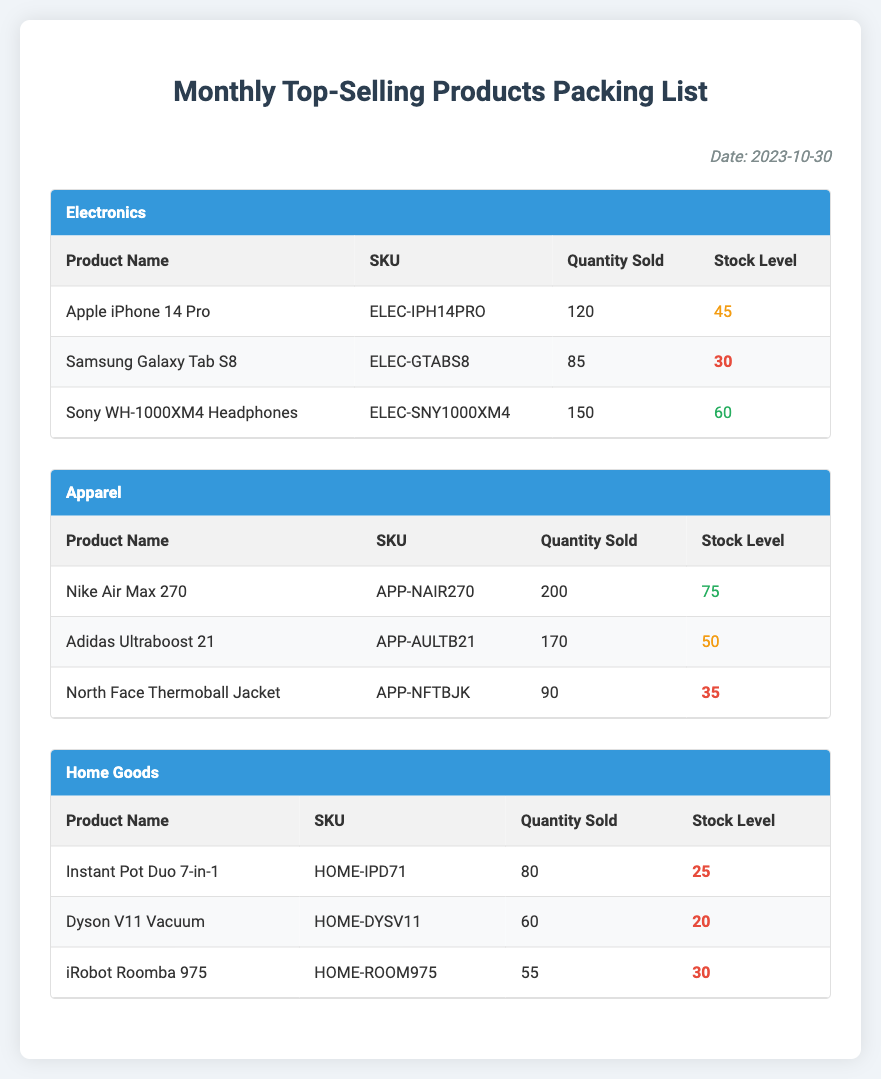What date is mentioned in the document? The document includes the date at the top right of the packing list, which is "2023-10-30."
Answer: 2023-10-30 How many quantities of the Apple iPhone 14 Pro were sold? The packing list shows that the quantity sold for the Apple iPhone 14 Pro is listed in the electronics category as "120."
Answer: 120 What is the stock level of the Dyson V11 Vacuum? The stock level for the Dyson V11 Vacuum can be found under the home goods category, which is "20."
Answer: 20 Which apparel product had the highest quantity sold? The apparel category shows that the Nike Air Max 270 had the highest quantity sold, which is "200."
Answer: Nike Air Max 270 How many products listed have a low stock level? By counting the entries, the document specifies that there are four products with a stock level categorized as low across different categories.
Answer: 4 What is the SKU of the Sony WH-1000XM4 Headphones? The SKU for the Sony WH-1000XM4 Headphones is presented in the electronics section as "ELEC-SNY1000XM4."
Answer: ELEC-SNY1000XM4 Which category has the product with the lowest stock level? The document indicates that home goods have the product with the lowest stock level, which is the Dyson V11 Vacuum at "20."
Answer: Home Goods How many products sold had a stock level classified as high? In the document, there are three products listed with stock levels categorized as high across the different sections.
Answer: 3 What is the stock level of the North Face Thermoball Jacket? The stock level for the North Face Thermoball Jacket is shown in the apparel category as "35."
Answer: 35 